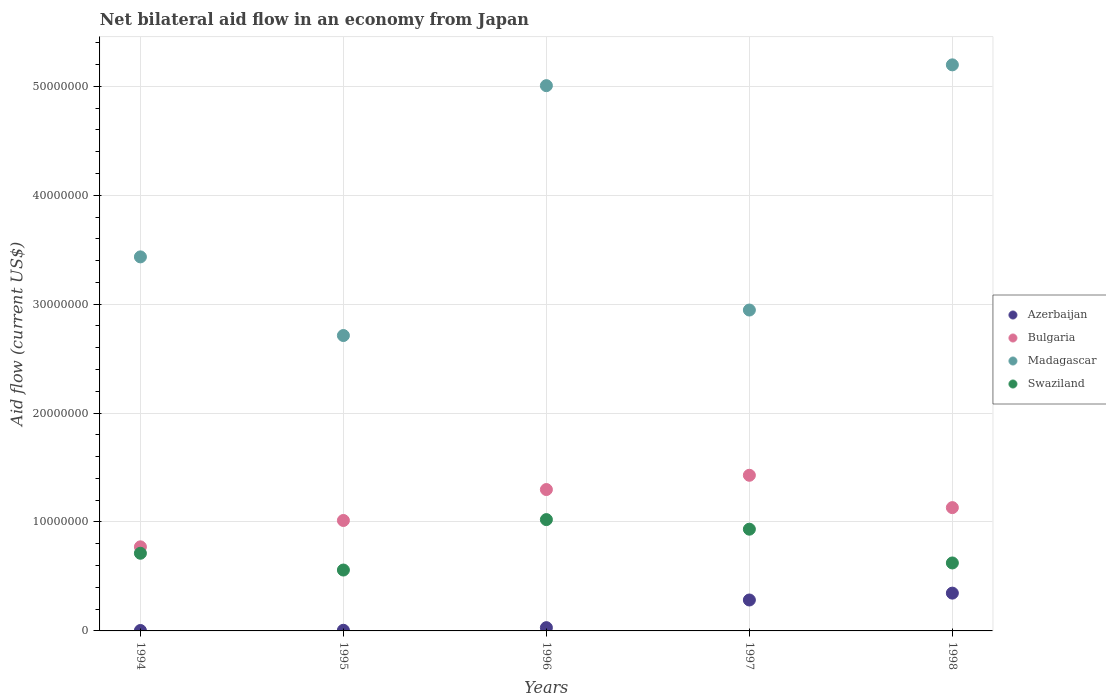Is the number of dotlines equal to the number of legend labels?
Ensure brevity in your answer.  Yes. What is the net bilateral aid flow in Bulgaria in 1998?
Your answer should be very brief. 1.13e+07. Across all years, what is the maximum net bilateral aid flow in Azerbaijan?
Make the answer very short. 3.47e+06. In which year was the net bilateral aid flow in Bulgaria maximum?
Ensure brevity in your answer.  1997. In which year was the net bilateral aid flow in Madagascar minimum?
Keep it short and to the point. 1995. What is the total net bilateral aid flow in Bulgaria in the graph?
Provide a short and direct response. 5.64e+07. What is the difference between the net bilateral aid flow in Bulgaria in 1995 and that in 1997?
Offer a very short reply. -4.15e+06. What is the difference between the net bilateral aid flow in Azerbaijan in 1998 and the net bilateral aid flow in Bulgaria in 1994?
Offer a terse response. -4.25e+06. What is the average net bilateral aid flow in Madagascar per year?
Provide a short and direct response. 3.86e+07. In the year 1997, what is the difference between the net bilateral aid flow in Madagascar and net bilateral aid flow in Bulgaria?
Offer a terse response. 1.52e+07. What is the ratio of the net bilateral aid flow in Bulgaria in 1996 to that in 1998?
Provide a succinct answer. 1.15. Is the net bilateral aid flow in Madagascar in 1994 less than that in 1998?
Your answer should be very brief. Yes. What is the difference between the highest and the second highest net bilateral aid flow in Swaziland?
Offer a very short reply. 8.80e+05. What is the difference between the highest and the lowest net bilateral aid flow in Bulgaria?
Provide a succinct answer. 6.57e+06. Is the sum of the net bilateral aid flow in Azerbaijan in 1994 and 1996 greater than the maximum net bilateral aid flow in Madagascar across all years?
Give a very brief answer. No. Does the net bilateral aid flow in Madagascar monotonically increase over the years?
Your answer should be very brief. No. Is the net bilateral aid flow in Madagascar strictly less than the net bilateral aid flow in Swaziland over the years?
Provide a succinct answer. No. How many dotlines are there?
Your answer should be compact. 4. What is the title of the graph?
Provide a short and direct response. Net bilateral aid flow in an economy from Japan. Does "Europe(developing only)" appear as one of the legend labels in the graph?
Keep it short and to the point. No. What is the label or title of the X-axis?
Your answer should be very brief. Years. What is the label or title of the Y-axis?
Offer a very short reply. Aid flow (current US$). What is the Aid flow (current US$) in Bulgaria in 1994?
Keep it short and to the point. 7.72e+06. What is the Aid flow (current US$) in Madagascar in 1994?
Make the answer very short. 3.43e+07. What is the Aid flow (current US$) of Swaziland in 1994?
Provide a succinct answer. 7.13e+06. What is the Aid flow (current US$) of Bulgaria in 1995?
Provide a succinct answer. 1.01e+07. What is the Aid flow (current US$) in Madagascar in 1995?
Make the answer very short. 2.71e+07. What is the Aid flow (current US$) of Swaziland in 1995?
Ensure brevity in your answer.  5.59e+06. What is the Aid flow (current US$) in Bulgaria in 1996?
Ensure brevity in your answer.  1.30e+07. What is the Aid flow (current US$) of Madagascar in 1996?
Your response must be concise. 5.01e+07. What is the Aid flow (current US$) of Swaziland in 1996?
Offer a terse response. 1.02e+07. What is the Aid flow (current US$) of Azerbaijan in 1997?
Offer a very short reply. 2.84e+06. What is the Aid flow (current US$) of Bulgaria in 1997?
Offer a very short reply. 1.43e+07. What is the Aid flow (current US$) of Madagascar in 1997?
Give a very brief answer. 2.95e+07. What is the Aid flow (current US$) of Swaziland in 1997?
Provide a short and direct response. 9.34e+06. What is the Aid flow (current US$) of Azerbaijan in 1998?
Give a very brief answer. 3.47e+06. What is the Aid flow (current US$) in Bulgaria in 1998?
Your answer should be very brief. 1.13e+07. What is the Aid flow (current US$) in Madagascar in 1998?
Provide a succinct answer. 5.20e+07. What is the Aid flow (current US$) of Swaziland in 1998?
Offer a very short reply. 6.24e+06. Across all years, what is the maximum Aid flow (current US$) in Azerbaijan?
Offer a very short reply. 3.47e+06. Across all years, what is the maximum Aid flow (current US$) in Bulgaria?
Offer a terse response. 1.43e+07. Across all years, what is the maximum Aid flow (current US$) of Madagascar?
Your response must be concise. 5.20e+07. Across all years, what is the maximum Aid flow (current US$) in Swaziland?
Ensure brevity in your answer.  1.02e+07. Across all years, what is the minimum Aid flow (current US$) of Bulgaria?
Offer a terse response. 7.72e+06. Across all years, what is the minimum Aid flow (current US$) of Madagascar?
Provide a short and direct response. 2.71e+07. Across all years, what is the minimum Aid flow (current US$) in Swaziland?
Provide a succinct answer. 5.59e+06. What is the total Aid flow (current US$) of Azerbaijan in the graph?
Your answer should be very brief. 6.71e+06. What is the total Aid flow (current US$) of Bulgaria in the graph?
Offer a terse response. 5.64e+07. What is the total Aid flow (current US$) of Madagascar in the graph?
Your response must be concise. 1.93e+08. What is the total Aid flow (current US$) of Swaziland in the graph?
Your answer should be very brief. 3.85e+07. What is the difference between the Aid flow (current US$) in Bulgaria in 1994 and that in 1995?
Give a very brief answer. -2.42e+06. What is the difference between the Aid flow (current US$) in Madagascar in 1994 and that in 1995?
Provide a short and direct response. 7.22e+06. What is the difference between the Aid flow (current US$) of Swaziland in 1994 and that in 1995?
Your answer should be very brief. 1.54e+06. What is the difference between the Aid flow (current US$) of Bulgaria in 1994 and that in 1996?
Your answer should be compact. -5.26e+06. What is the difference between the Aid flow (current US$) of Madagascar in 1994 and that in 1996?
Keep it short and to the point. -1.57e+07. What is the difference between the Aid flow (current US$) in Swaziland in 1994 and that in 1996?
Offer a very short reply. -3.09e+06. What is the difference between the Aid flow (current US$) of Azerbaijan in 1994 and that in 1997?
Give a very brief answer. -2.80e+06. What is the difference between the Aid flow (current US$) in Bulgaria in 1994 and that in 1997?
Provide a short and direct response. -6.57e+06. What is the difference between the Aid flow (current US$) in Madagascar in 1994 and that in 1997?
Make the answer very short. 4.88e+06. What is the difference between the Aid flow (current US$) in Swaziland in 1994 and that in 1997?
Your response must be concise. -2.21e+06. What is the difference between the Aid flow (current US$) of Azerbaijan in 1994 and that in 1998?
Offer a very short reply. -3.43e+06. What is the difference between the Aid flow (current US$) in Bulgaria in 1994 and that in 1998?
Your answer should be compact. -3.60e+06. What is the difference between the Aid flow (current US$) in Madagascar in 1994 and that in 1998?
Provide a succinct answer. -1.76e+07. What is the difference between the Aid flow (current US$) in Swaziland in 1994 and that in 1998?
Give a very brief answer. 8.90e+05. What is the difference between the Aid flow (current US$) in Bulgaria in 1995 and that in 1996?
Your answer should be compact. -2.84e+06. What is the difference between the Aid flow (current US$) of Madagascar in 1995 and that in 1996?
Keep it short and to the point. -2.29e+07. What is the difference between the Aid flow (current US$) of Swaziland in 1995 and that in 1996?
Your response must be concise. -4.63e+06. What is the difference between the Aid flow (current US$) of Azerbaijan in 1995 and that in 1997?
Provide a succinct answer. -2.78e+06. What is the difference between the Aid flow (current US$) of Bulgaria in 1995 and that in 1997?
Offer a terse response. -4.15e+06. What is the difference between the Aid flow (current US$) in Madagascar in 1995 and that in 1997?
Give a very brief answer. -2.34e+06. What is the difference between the Aid flow (current US$) of Swaziland in 1995 and that in 1997?
Make the answer very short. -3.75e+06. What is the difference between the Aid flow (current US$) of Azerbaijan in 1995 and that in 1998?
Your answer should be compact. -3.41e+06. What is the difference between the Aid flow (current US$) in Bulgaria in 1995 and that in 1998?
Ensure brevity in your answer.  -1.18e+06. What is the difference between the Aid flow (current US$) of Madagascar in 1995 and that in 1998?
Give a very brief answer. -2.48e+07. What is the difference between the Aid flow (current US$) in Swaziland in 1995 and that in 1998?
Your answer should be very brief. -6.50e+05. What is the difference between the Aid flow (current US$) of Azerbaijan in 1996 and that in 1997?
Provide a short and direct response. -2.54e+06. What is the difference between the Aid flow (current US$) in Bulgaria in 1996 and that in 1997?
Make the answer very short. -1.31e+06. What is the difference between the Aid flow (current US$) of Madagascar in 1996 and that in 1997?
Provide a short and direct response. 2.06e+07. What is the difference between the Aid flow (current US$) in Swaziland in 1996 and that in 1997?
Offer a very short reply. 8.80e+05. What is the difference between the Aid flow (current US$) of Azerbaijan in 1996 and that in 1998?
Keep it short and to the point. -3.17e+06. What is the difference between the Aid flow (current US$) in Bulgaria in 1996 and that in 1998?
Make the answer very short. 1.66e+06. What is the difference between the Aid flow (current US$) of Madagascar in 1996 and that in 1998?
Offer a terse response. -1.91e+06. What is the difference between the Aid flow (current US$) in Swaziland in 1996 and that in 1998?
Make the answer very short. 3.98e+06. What is the difference between the Aid flow (current US$) in Azerbaijan in 1997 and that in 1998?
Keep it short and to the point. -6.30e+05. What is the difference between the Aid flow (current US$) in Bulgaria in 1997 and that in 1998?
Make the answer very short. 2.97e+06. What is the difference between the Aid flow (current US$) of Madagascar in 1997 and that in 1998?
Make the answer very short. -2.25e+07. What is the difference between the Aid flow (current US$) of Swaziland in 1997 and that in 1998?
Provide a short and direct response. 3.10e+06. What is the difference between the Aid flow (current US$) in Azerbaijan in 1994 and the Aid flow (current US$) in Bulgaria in 1995?
Your answer should be very brief. -1.01e+07. What is the difference between the Aid flow (current US$) of Azerbaijan in 1994 and the Aid flow (current US$) of Madagascar in 1995?
Offer a very short reply. -2.71e+07. What is the difference between the Aid flow (current US$) of Azerbaijan in 1994 and the Aid flow (current US$) of Swaziland in 1995?
Provide a succinct answer. -5.55e+06. What is the difference between the Aid flow (current US$) of Bulgaria in 1994 and the Aid flow (current US$) of Madagascar in 1995?
Give a very brief answer. -1.94e+07. What is the difference between the Aid flow (current US$) in Bulgaria in 1994 and the Aid flow (current US$) in Swaziland in 1995?
Ensure brevity in your answer.  2.13e+06. What is the difference between the Aid flow (current US$) in Madagascar in 1994 and the Aid flow (current US$) in Swaziland in 1995?
Keep it short and to the point. 2.88e+07. What is the difference between the Aid flow (current US$) in Azerbaijan in 1994 and the Aid flow (current US$) in Bulgaria in 1996?
Provide a succinct answer. -1.29e+07. What is the difference between the Aid flow (current US$) in Azerbaijan in 1994 and the Aid flow (current US$) in Madagascar in 1996?
Your answer should be very brief. -5.00e+07. What is the difference between the Aid flow (current US$) of Azerbaijan in 1994 and the Aid flow (current US$) of Swaziland in 1996?
Your response must be concise. -1.02e+07. What is the difference between the Aid flow (current US$) of Bulgaria in 1994 and the Aid flow (current US$) of Madagascar in 1996?
Your response must be concise. -4.23e+07. What is the difference between the Aid flow (current US$) of Bulgaria in 1994 and the Aid flow (current US$) of Swaziland in 1996?
Offer a terse response. -2.50e+06. What is the difference between the Aid flow (current US$) in Madagascar in 1994 and the Aid flow (current US$) in Swaziland in 1996?
Keep it short and to the point. 2.41e+07. What is the difference between the Aid flow (current US$) in Azerbaijan in 1994 and the Aid flow (current US$) in Bulgaria in 1997?
Provide a short and direct response. -1.42e+07. What is the difference between the Aid flow (current US$) of Azerbaijan in 1994 and the Aid flow (current US$) of Madagascar in 1997?
Your answer should be compact. -2.94e+07. What is the difference between the Aid flow (current US$) in Azerbaijan in 1994 and the Aid flow (current US$) in Swaziland in 1997?
Give a very brief answer. -9.30e+06. What is the difference between the Aid flow (current US$) of Bulgaria in 1994 and the Aid flow (current US$) of Madagascar in 1997?
Ensure brevity in your answer.  -2.17e+07. What is the difference between the Aid flow (current US$) in Bulgaria in 1994 and the Aid flow (current US$) in Swaziland in 1997?
Give a very brief answer. -1.62e+06. What is the difference between the Aid flow (current US$) in Madagascar in 1994 and the Aid flow (current US$) in Swaziland in 1997?
Provide a short and direct response. 2.50e+07. What is the difference between the Aid flow (current US$) of Azerbaijan in 1994 and the Aid flow (current US$) of Bulgaria in 1998?
Give a very brief answer. -1.13e+07. What is the difference between the Aid flow (current US$) in Azerbaijan in 1994 and the Aid flow (current US$) in Madagascar in 1998?
Make the answer very short. -5.19e+07. What is the difference between the Aid flow (current US$) in Azerbaijan in 1994 and the Aid flow (current US$) in Swaziland in 1998?
Your answer should be compact. -6.20e+06. What is the difference between the Aid flow (current US$) in Bulgaria in 1994 and the Aid flow (current US$) in Madagascar in 1998?
Your answer should be compact. -4.42e+07. What is the difference between the Aid flow (current US$) of Bulgaria in 1994 and the Aid flow (current US$) of Swaziland in 1998?
Make the answer very short. 1.48e+06. What is the difference between the Aid flow (current US$) of Madagascar in 1994 and the Aid flow (current US$) of Swaziland in 1998?
Provide a succinct answer. 2.81e+07. What is the difference between the Aid flow (current US$) of Azerbaijan in 1995 and the Aid flow (current US$) of Bulgaria in 1996?
Your response must be concise. -1.29e+07. What is the difference between the Aid flow (current US$) in Azerbaijan in 1995 and the Aid flow (current US$) in Madagascar in 1996?
Offer a terse response. -5.00e+07. What is the difference between the Aid flow (current US$) in Azerbaijan in 1995 and the Aid flow (current US$) in Swaziland in 1996?
Make the answer very short. -1.02e+07. What is the difference between the Aid flow (current US$) in Bulgaria in 1995 and the Aid flow (current US$) in Madagascar in 1996?
Your answer should be compact. -3.99e+07. What is the difference between the Aid flow (current US$) in Bulgaria in 1995 and the Aid flow (current US$) in Swaziland in 1996?
Keep it short and to the point. -8.00e+04. What is the difference between the Aid flow (current US$) in Madagascar in 1995 and the Aid flow (current US$) in Swaziland in 1996?
Your answer should be compact. 1.69e+07. What is the difference between the Aid flow (current US$) of Azerbaijan in 1995 and the Aid flow (current US$) of Bulgaria in 1997?
Ensure brevity in your answer.  -1.42e+07. What is the difference between the Aid flow (current US$) in Azerbaijan in 1995 and the Aid flow (current US$) in Madagascar in 1997?
Give a very brief answer. -2.94e+07. What is the difference between the Aid flow (current US$) in Azerbaijan in 1995 and the Aid flow (current US$) in Swaziland in 1997?
Your response must be concise. -9.28e+06. What is the difference between the Aid flow (current US$) in Bulgaria in 1995 and the Aid flow (current US$) in Madagascar in 1997?
Your answer should be very brief. -1.93e+07. What is the difference between the Aid flow (current US$) in Madagascar in 1995 and the Aid flow (current US$) in Swaziland in 1997?
Keep it short and to the point. 1.78e+07. What is the difference between the Aid flow (current US$) of Azerbaijan in 1995 and the Aid flow (current US$) of Bulgaria in 1998?
Offer a terse response. -1.13e+07. What is the difference between the Aid flow (current US$) in Azerbaijan in 1995 and the Aid flow (current US$) in Madagascar in 1998?
Provide a short and direct response. -5.19e+07. What is the difference between the Aid flow (current US$) of Azerbaijan in 1995 and the Aid flow (current US$) of Swaziland in 1998?
Keep it short and to the point. -6.18e+06. What is the difference between the Aid flow (current US$) in Bulgaria in 1995 and the Aid flow (current US$) in Madagascar in 1998?
Your answer should be compact. -4.18e+07. What is the difference between the Aid flow (current US$) in Bulgaria in 1995 and the Aid flow (current US$) in Swaziland in 1998?
Offer a very short reply. 3.90e+06. What is the difference between the Aid flow (current US$) of Madagascar in 1995 and the Aid flow (current US$) of Swaziland in 1998?
Ensure brevity in your answer.  2.09e+07. What is the difference between the Aid flow (current US$) of Azerbaijan in 1996 and the Aid flow (current US$) of Bulgaria in 1997?
Provide a short and direct response. -1.40e+07. What is the difference between the Aid flow (current US$) in Azerbaijan in 1996 and the Aid flow (current US$) in Madagascar in 1997?
Keep it short and to the point. -2.92e+07. What is the difference between the Aid flow (current US$) of Azerbaijan in 1996 and the Aid flow (current US$) of Swaziland in 1997?
Your answer should be compact. -9.04e+06. What is the difference between the Aid flow (current US$) in Bulgaria in 1996 and the Aid flow (current US$) in Madagascar in 1997?
Give a very brief answer. -1.65e+07. What is the difference between the Aid flow (current US$) in Bulgaria in 1996 and the Aid flow (current US$) in Swaziland in 1997?
Provide a short and direct response. 3.64e+06. What is the difference between the Aid flow (current US$) of Madagascar in 1996 and the Aid flow (current US$) of Swaziland in 1997?
Provide a short and direct response. 4.07e+07. What is the difference between the Aid flow (current US$) of Azerbaijan in 1996 and the Aid flow (current US$) of Bulgaria in 1998?
Your answer should be very brief. -1.10e+07. What is the difference between the Aid flow (current US$) of Azerbaijan in 1996 and the Aid flow (current US$) of Madagascar in 1998?
Your answer should be very brief. -5.17e+07. What is the difference between the Aid flow (current US$) of Azerbaijan in 1996 and the Aid flow (current US$) of Swaziland in 1998?
Offer a terse response. -5.94e+06. What is the difference between the Aid flow (current US$) of Bulgaria in 1996 and the Aid flow (current US$) of Madagascar in 1998?
Provide a short and direct response. -3.90e+07. What is the difference between the Aid flow (current US$) of Bulgaria in 1996 and the Aid flow (current US$) of Swaziland in 1998?
Give a very brief answer. 6.74e+06. What is the difference between the Aid flow (current US$) in Madagascar in 1996 and the Aid flow (current US$) in Swaziland in 1998?
Provide a succinct answer. 4.38e+07. What is the difference between the Aid flow (current US$) of Azerbaijan in 1997 and the Aid flow (current US$) of Bulgaria in 1998?
Your response must be concise. -8.48e+06. What is the difference between the Aid flow (current US$) in Azerbaijan in 1997 and the Aid flow (current US$) in Madagascar in 1998?
Your response must be concise. -4.91e+07. What is the difference between the Aid flow (current US$) of Azerbaijan in 1997 and the Aid flow (current US$) of Swaziland in 1998?
Your answer should be very brief. -3.40e+06. What is the difference between the Aid flow (current US$) in Bulgaria in 1997 and the Aid flow (current US$) in Madagascar in 1998?
Make the answer very short. -3.77e+07. What is the difference between the Aid flow (current US$) in Bulgaria in 1997 and the Aid flow (current US$) in Swaziland in 1998?
Make the answer very short. 8.05e+06. What is the difference between the Aid flow (current US$) of Madagascar in 1997 and the Aid flow (current US$) of Swaziland in 1998?
Keep it short and to the point. 2.32e+07. What is the average Aid flow (current US$) in Azerbaijan per year?
Keep it short and to the point. 1.34e+06. What is the average Aid flow (current US$) in Bulgaria per year?
Offer a terse response. 1.13e+07. What is the average Aid flow (current US$) of Madagascar per year?
Provide a succinct answer. 3.86e+07. What is the average Aid flow (current US$) in Swaziland per year?
Provide a succinct answer. 7.70e+06. In the year 1994, what is the difference between the Aid flow (current US$) of Azerbaijan and Aid flow (current US$) of Bulgaria?
Your response must be concise. -7.68e+06. In the year 1994, what is the difference between the Aid flow (current US$) of Azerbaijan and Aid flow (current US$) of Madagascar?
Your answer should be very brief. -3.43e+07. In the year 1994, what is the difference between the Aid flow (current US$) of Azerbaijan and Aid flow (current US$) of Swaziland?
Provide a short and direct response. -7.09e+06. In the year 1994, what is the difference between the Aid flow (current US$) of Bulgaria and Aid flow (current US$) of Madagascar?
Ensure brevity in your answer.  -2.66e+07. In the year 1994, what is the difference between the Aid flow (current US$) in Bulgaria and Aid flow (current US$) in Swaziland?
Offer a very short reply. 5.90e+05. In the year 1994, what is the difference between the Aid flow (current US$) of Madagascar and Aid flow (current US$) of Swaziland?
Your answer should be compact. 2.72e+07. In the year 1995, what is the difference between the Aid flow (current US$) of Azerbaijan and Aid flow (current US$) of Bulgaria?
Provide a succinct answer. -1.01e+07. In the year 1995, what is the difference between the Aid flow (current US$) of Azerbaijan and Aid flow (current US$) of Madagascar?
Give a very brief answer. -2.71e+07. In the year 1995, what is the difference between the Aid flow (current US$) of Azerbaijan and Aid flow (current US$) of Swaziland?
Ensure brevity in your answer.  -5.53e+06. In the year 1995, what is the difference between the Aid flow (current US$) of Bulgaria and Aid flow (current US$) of Madagascar?
Ensure brevity in your answer.  -1.70e+07. In the year 1995, what is the difference between the Aid flow (current US$) in Bulgaria and Aid flow (current US$) in Swaziland?
Ensure brevity in your answer.  4.55e+06. In the year 1995, what is the difference between the Aid flow (current US$) of Madagascar and Aid flow (current US$) of Swaziland?
Give a very brief answer. 2.15e+07. In the year 1996, what is the difference between the Aid flow (current US$) in Azerbaijan and Aid flow (current US$) in Bulgaria?
Keep it short and to the point. -1.27e+07. In the year 1996, what is the difference between the Aid flow (current US$) in Azerbaijan and Aid flow (current US$) in Madagascar?
Your answer should be very brief. -4.98e+07. In the year 1996, what is the difference between the Aid flow (current US$) in Azerbaijan and Aid flow (current US$) in Swaziland?
Your answer should be very brief. -9.92e+06. In the year 1996, what is the difference between the Aid flow (current US$) in Bulgaria and Aid flow (current US$) in Madagascar?
Ensure brevity in your answer.  -3.71e+07. In the year 1996, what is the difference between the Aid flow (current US$) in Bulgaria and Aid flow (current US$) in Swaziland?
Your answer should be very brief. 2.76e+06. In the year 1996, what is the difference between the Aid flow (current US$) in Madagascar and Aid flow (current US$) in Swaziland?
Give a very brief answer. 3.98e+07. In the year 1997, what is the difference between the Aid flow (current US$) in Azerbaijan and Aid flow (current US$) in Bulgaria?
Offer a very short reply. -1.14e+07. In the year 1997, what is the difference between the Aid flow (current US$) of Azerbaijan and Aid flow (current US$) of Madagascar?
Your answer should be very brief. -2.66e+07. In the year 1997, what is the difference between the Aid flow (current US$) in Azerbaijan and Aid flow (current US$) in Swaziland?
Offer a very short reply. -6.50e+06. In the year 1997, what is the difference between the Aid flow (current US$) of Bulgaria and Aid flow (current US$) of Madagascar?
Give a very brief answer. -1.52e+07. In the year 1997, what is the difference between the Aid flow (current US$) in Bulgaria and Aid flow (current US$) in Swaziland?
Keep it short and to the point. 4.95e+06. In the year 1997, what is the difference between the Aid flow (current US$) in Madagascar and Aid flow (current US$) in Swaziland?
Keep it short and to the point. 2.01e+07. In the year 1998, what is the difference between the Aid flow (current US$) in Azerbaijan and Aid flow (current US$) in Bulgaria?
Your answer should be compact. -7.85e+06. In the year 1998, what is the difference between the Aid flow (current US$) in Azerbaijan and Aid flow (current US$) in Madagascar?
Ensure brevity in your answer.  -4.85e+07. In the year 1998, what is the difference between the Aid flow (current US$) in Azerbaijan and Aid flow (current US$) in Swaziland?
Offer a terse response. -2.77e+06. In the year 1998, what is the difference between the Aid flow (current US$) in Bulgaria and Aid flow (current US$) in Madagascar?
Your response must be concise. -4.06e+07. In the year 1998, what is the difference between the Aid flow (current US$) in Bulgaria and Aid flow (current US$) in Swaziland?
Offer a very short reply. 5.08e+06. In the year 1998, what is the difference between the Aid flow (current US$) of Madagascar and Aid flow (current US$) of Swaziland?
Ensure brevity in your answer.  4.57e+07. What is the ratio of the Aid flow (current US$) in Azerbaijan in 1994 to that in 1995?
Your answer should be compact. 0.67. What is the ratio of the Aid flow (current US$) in Bulgaria in 1994 to that in 1995?
Offer a very short reply. 0.76. What is the ratio of the Aid flow (current US$) of Madagascar in 1994 to that in 1995?
Ensure brevity in your answer.  1.27. What is the ratio of the Aid flow (current US$) of Swaziland in 1994 to that in 1995?
Your answer should be compact. 1.28. What is the ratio of the Aid flow (current US$) of Azerbaijan in 1994 to that in 1996?
Your response must be concise. 0.13. What is the ratio of the Aid flow (current US$) of Bulgaria in 1994 to that in 1996?
Your answer should be compact. 0.59. What is the ratio of the Aid flow (current US$) in Madagascar in 1994 to that in 1996?
Offer a very short reply. 0.69. What is the ratio of the Aid flow (current US$) of Swaziland in 1994 to that in 1996?
Provide a short and direct response. 0.7. What is the ratio of the Aid flow (current US$) in Azerbaijan in 1994 to that in 1997?
Ensure brevity in your answer.  0.01. What is the ratio of the Aid flow (current US$) of Bulgaria in 1994 to that in 1997?
Offer a very short reply. 0.54. What is the ratio of the Aid flow (current US$) in Madagascar in 1994 to that in 1997?
Your answer should be compact. 1.17. What is the ratio of the Aid flow (current US$) of Swaziland in 1994 to that in 1997?
Your answer should be very brief. 0.76. What is the ratio of the Aid flow (current US$) of Azerbaijan in 1994 to that in 1998?
Provide a short and direct response. 0.01. What is the ratio of the Aid flow (current US$) in Bulgaria in 1994 to that in 1998?
Offer a very short reply. 0.68. What is the ratio of the Aid flow (current US$) of Madagascar in 1994 to that in 1998?
Make the answer very short. 0.66. What is the ratio of the Aid flow (current US$) in Swaziland in 1994 to that in 1998?
Provide a short and direct response. 1.14. What is the ratio of the Aid flow (current US$) in Bulgaria in 1995 to that in 1996?
Offer a very short reply. 0.78. What is the ratio of the Aid flow (current US$) in Madagascar in 1995 to that in 1996?
Your answer should be very brief. 0.54. What is the ratio of the Aid flow (current US$) of Swaziland in 1995 to that in 1996?
Provide a succinct answer. 0.55. What is the ratio of the Aid flow (current US$) in Azerbaijan in 1995 to that in 1997?
Keep it short and to the point. 0.02. What is the ratio of the Aid flow (current US$) in Bulgaria in 1995 to that in 1997?
Make the answer very short. 0.71. What is the ratio of the Aid flow (current US$) in Madagascar in 1995 to that in 1997?
Provide a short and direct response. 0.92. What is the ratio of the Aid flow (current US$) in Swaziland in 1995 to that in 1997?
Your answer should be compact. 0.6. What is the ratio of the Aid flow (current US$) of Azerbaijan in 1995 to that in 1998?
Offer a very short reply. 0.02. What is the ratio of the Aid flow (current US$) of Bulgaria in 1995 to that in 1998?
Give a very brief answer. 0.9. What is the ratio of the Aid flow (current US$) in Madagascar in 1995 to that in 1998?
Give a very brief answer. 0.52. What is the ratio of the Aid flow (current US$) in Swaziland in 1995 to that in 1998?
Give a very brief answer. 0.9. What is the ratio of the Aid flow (current US$) of Azerbaijan in 1996 to that in 1997?
Keep it short and to the point. 0.11. What is the ratio of the Aid flow (current US$) in Bulgaria in 1996 to that in 1997?
Keep it short and to the point. 0.91. What is the ratio of the Aid flow (current US$) in Madagascar in 1996 to that in 1997?
Offer a terse response. 1.7. What is the ratio of the Aid flow (current US$) in Swaziland in 1996 to that in 1997?
Provide a succinct answer. 1.09. What is the ratio of the Aid flow (current US$) of Azerbaijan in 1996 to that in 1998?
Offer a very short reply. 0.09. What is the ratio of the Aid flow (current US$) in Bulgaria in 1996 to that in 1998?
Give a very brief answer. 1.15. What is the ratio of the Aid flow (current US$) of Madagascar in 1996 to that in 1998?
Offer a very short reply. 0.96. What is the ratio of the Aid flow (current US$) in Swaziland in 1996 to that in 1998?
Ensure brevity in your answer.  1.64. What is the ratio of the Aid flow (current US$) in Azerbaijan in 1997 to that in 1998?
Offer a terse response. 0.82. What is the ratio of the Aid flow (current US$) of Bulgaria in 1997 to that in 1998?
Ensure brevity in your answer.  1.26. What is the ratio of the Aid flow (current US$) of Madagascar in 1997 to that in 1998?
Provide a short and direct response. 0.57. What is the ratio of the Aid flow (current US$) of Swaziland in 1997 to that in 1998?
Your answer should be very brief. 1.5. What is the difference between the highest and the second highest Aid flow (current US$) in Azerbaijan?
Make the answer very short. 6.30e+05. What is the difference between the highest and the second highest Aid flow (current US$) in Bulgaria?
Make the answer very short. 1.31e+06. What is the difference between the highest and the second highest Aid flow (current US$) in Madagascar?
Give a very brief answer. 1.91e+06. What is the difference between the highest and the second highest Aid flow (current US$) in Swaziland?
Provide a short and direct response. 8.80e+05. What is the difference between the highest and the lowest Aid flow (current US$) in Azerbaijan?
Offer a terse response. 3.43e+06. What is the difference between the highest and the lowest Aid flow (current US$) in Bulgaria?
Make the answer very short. 6.57e+06. What is the difference between the highest and the lowest Aid flow (current US$) of Madagascar?
Your answer should be compact. 2.48e+07. What is the difference between the highest and the lowest Aid flow (current US$) in Swaziland?
Your answer should be compact. 4.63e+06. 